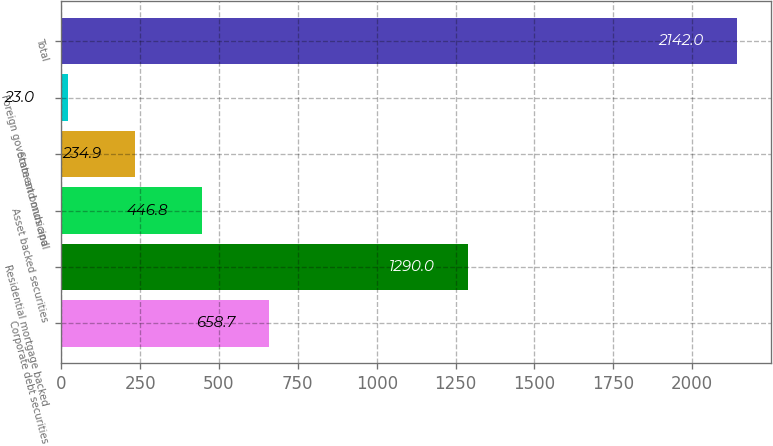<chart> <loc_0><loc_0><loc_500><loc_500><bar_chart><fcel>Corporate debt securities<fcel>Residential mortgage backed<fcel>Asset backed securities<fcel>State and municipal<fcel>Foreign government bonds and<fcel>Total<nl><fcel>658.7<fcel>1290<fcel>446.8<fcel>234.9<fcel>23<fcel>2142<nl></chart> 